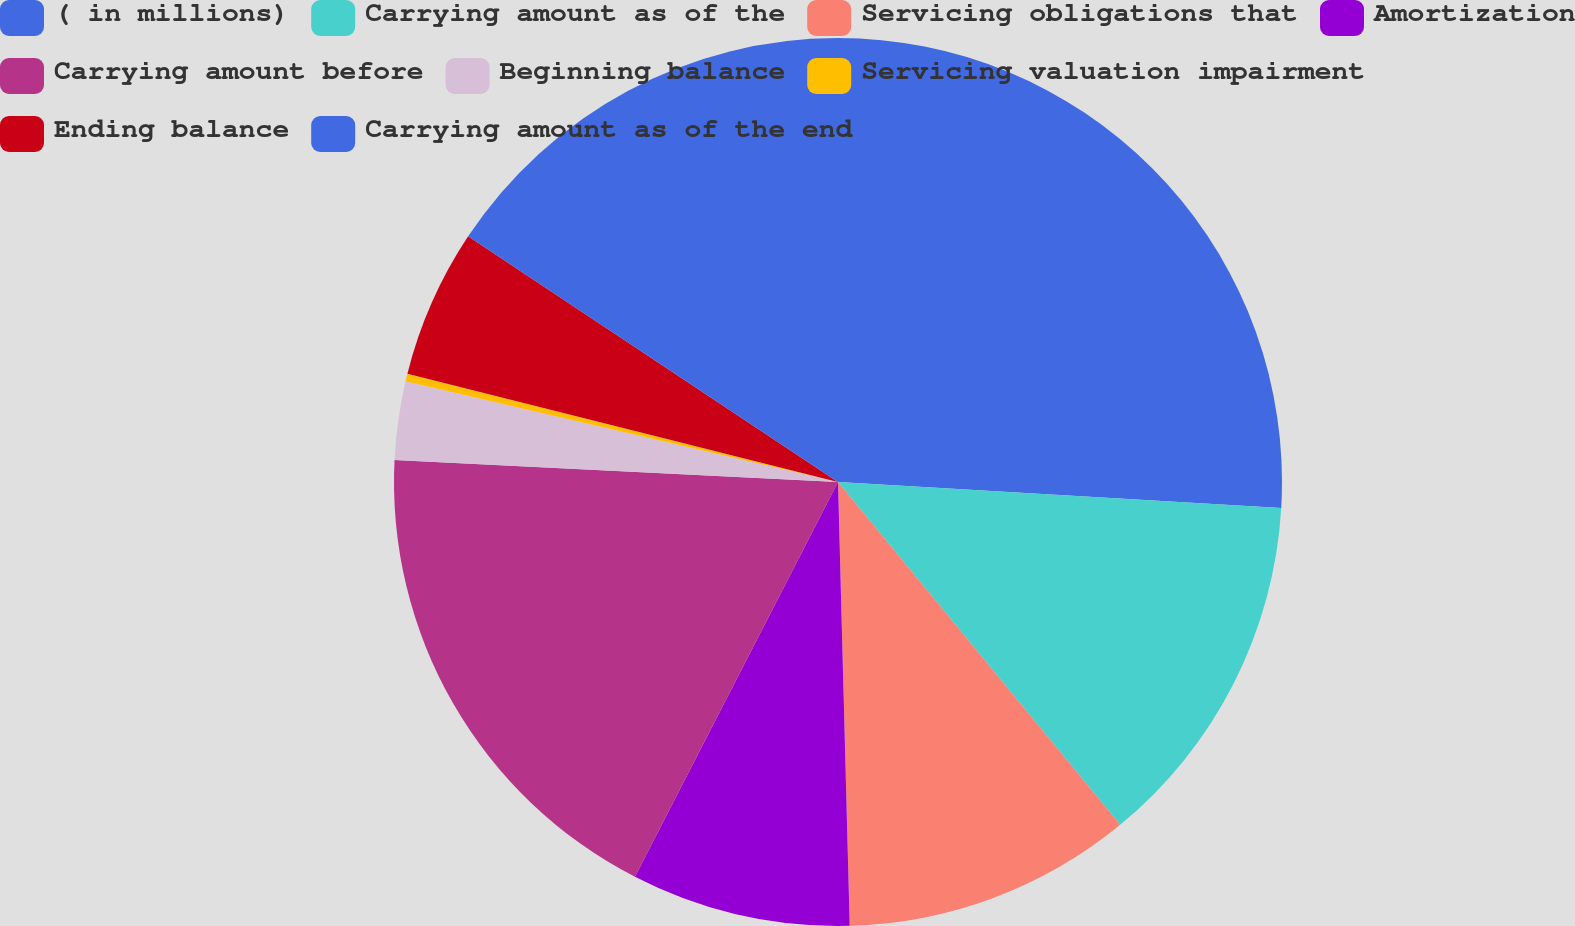Convert chart. <chart><loc_0><loc_0><loc_500><loc_500><pie_chart><fcel>( in millions)<fcel>Carrying amount as of the<fcel>Servicing obligations that<fcel>Amortization<fcel>Carrying amount before<fcel>Beginning balance<fcel>Servicing valuation impairment<fcel>Ending balance<fcel>Carrying amount as of the end<nl><fcel>25.93%<fcel>13.11%<fcel>10.54%<fcel>7.98%<fcel>18.23%<fcel>2.85%<fcel>0.28%<fcel>5.41%<fcel>15.67%<nl></chart> 